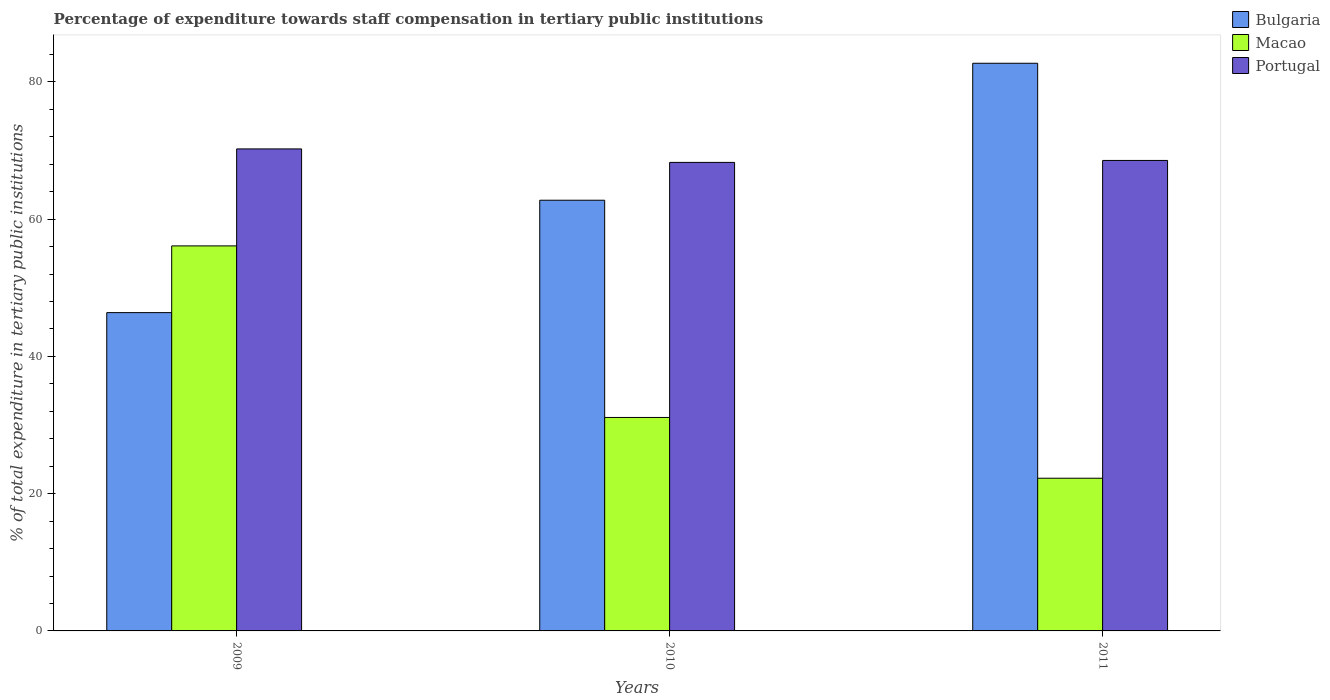Are the number of bars on each tick of the X-axis equal?
Keep it short and to the point. Yes. What is the label of the 2nd group of bars from the left?
Your answer should be compact. 2010. In how many cases, is the number of bars for a given year not equal to the number of legend labels?
Ensure brevity in your answer.  0. What is the percentage of expenditure towards staff compensation in Portugal in 2010?
Your answer should be very brief. 68.27. Across all years, what is the maximum percentage of expenditure towards staff compensation in Bulgaria?
Give a very brief answer. 82.72. Across all years, what is the minimum percentage of expenditure towards staff compensation in Portugal?
Give a very brief answer. 68.27. In which year was the percentage of expenditure towards staff compensation in Macao maximum?
Ensure brevity in your answer.  2009. What is the total percentage of expenditure towards staff compensation in Portugal in the graph?
Offer a terse response. 207.06. What is the difference between the percentage of expenditure towards staff compensation in Macao in 2009 and that in 2010?
Make the answer very short. 25. What is the difference between the percentage of expenditure towards staff compensation in Bulgaria in 2011 and the percentage of expenditure towards staff compensation in Macao in 2010?
Keep it short and to the point. 51.61. What is the average percentage of expenditure towards staff compensation in Portugal per year?
Provide a short and direct response. 69.02. In the year 2009, what is the difference between the percentage of expenditure towards staff compensation in Portugal and percentage of expenditure towards staff compensation in Macao?
Make the answer very short. 14.13. What is the ratio of the percentage of expenditure towards staff compensation in Macao in 2009 to that in 2010?
Give a very brief answer. 1.8. What is the difference between the highest and the second highest percentage of expenditure towards staff compensation in Macao?
Make the answer very short. 25. What is the difference between the highest and the lowest percentage of expenditure towards staff compensation in Portugal?
Give a very brief answer. 1.96. Is the sum of the percentage of expenditure towards staff compensation in Portugal in 2009 and 2011 greater than the maximum percentage of expenditure towards staff compensation in Bulgaria across all years?
Your response must be concise. Yes. How many bars are there?
Give a very brief answer. 9. How many years are there in the graph?
Offer a terse response. 3. What is the difference between two consecutive major ticks on the Y-axis?
Ensure brevity in your answer.  20. Does the graph contain any zero values?
Give a very brief answer. No. Does the graph contain grids?
Provide a succinct answer. No. Where does the legend appear in the graph?
Keep it short and to the point. Top right. How many legend labels are there?
Your response must be concise. 3. What is the title of the graph?
Offer a terse response. Percentage of expenditure towards staff compensation in tertiary public institutions. Does "Norway" appear as one of the legend labels in the graph?
Offer a terse response. No. What is the label or title of the X-axis?
Your answer should be very brief. Years. What is the label or title of the Y-axis?
Give a very brief answer. % of total expenditure in tertiary public institutions. What is the % of total expenditure in tertiary public institutions in Bulgaria in 2009?
Make the answer very short. 46.38. What is the % of total expenditure in tertiary public institutions in Macao in 2009?
Keep it short and to the point. 56.1. What is the % of total expenditure in tertiary public institutions of Portugal in 2009?
Give a very brief answer. 70.24. What is the % of total expenditure in tertiary public institutions in Bulgaria in 2010?
Your answer should be compact. 62.76. What is the % of total expenditure in tertiary public institutions in Macao in 2010?
Provide a succinct answer. 31.1. What is the % of total expenditure in tertiary public institutions in Portugal in 2010?
Keep it short and to the point. 68.27. What is the % of total expenditure in tertiary public institutions in Bulgaria in 2011?
Provide a succinct answer. 82.72. What is the % of total expenditure in tertiary public institutions of Macao in 2011?
Provide a succinct answer. 22.25. What is the % of total expenditure in tertiary public institutions of Portugal in 2011?
Keep it short and to the point. 68.56. Across all years, what is the maximum % of total expenditure in tertiary public institutions of Bulgaria?
Ensure brevity in your answer.  82.72. Across all years, what is the maximum % of total expenditure in tertiary public institutions of Macao?
Keep it short and to the point. 56.1. Across all years, what is the maximum % of total expenditure in tertiary public institutions in Portugal?
Ensure brevity in your answer.  70.24. Across all years, what is the minimum % of total expenditure in tertiary public institutions in Bulgaria?
Provide a succinct answer. 46.38. Across all years, what is the minimum % of total expenditure in tertiary public institutions in Macao?
Ensure brevity in your answer.  22.25. Across all years, what is the minimum % of total expenditure in tertiary public institutions in Portugal?
Your answer should be very brief. 68.27. What is the total % of total expenditure in tertiary public institutions of Bulgaria in the graph?
Provide a short and direct response. 191.86. What is the total % of total expenditure in tertiary public institutions of Macao in the graph?
Make the answer very short. 109.46. What is the total % of total expenditure in tertiary public institutions of Portugal in the graph?
Keep it short and to the point. 207.06. What is the difference between the % of total expenditure in tertiary public institutions in Bulgaria in 2009 and that in 2010?
Ensure brevity in your answer.  -16.38. What is the difference between the % of total expenditure in tertiary public institutions of Macao in 2009 and that in 2010?
Provide a succinct answer. 25. What is the difference between the % of total expenditure in tertiary public institutions of Portugal in 2009 and that in 2010?
Keep it short and to the point. 1.96. What is the difference between the % of total expenditure in tertiary public institutions in Bulgaria in 2009 and that in 2011?
Provide a succinct answer. -36.34. What is the difference between the % of total expenditure in tertiary public institutions in Macao in 2009 and that in 2011?
Make the answer very short. 33.85. What is the difference between the % of total expenditure in tertiary public institutions of Portugal in 2009 and that in 2011?
Make the answer very short. 1.68. What is the difference between the % of total expenditure in tertiary public institutions in Bulgaria in 2010 and that in 2011?
Provide a succinct answer. -19.96. What is the difference between the % of total expenditure in tertiary public institutions in Macao in 2010 and that in 2011?
Offer a terse response. 8.85. What is the difference between the % of total expenditure in tertiary public institutions in Portugal in 2010 and that in 2011?
Offer a terse response. -0.28. What is the difference between the % of total expenditure in tertiary public institutions of Bulgaria in 2009 and the % of total expenditure in tertiary public institutions of Macao in 2010?
Give a very brief answer. 15.28. What is the difference between the % of total expenditure in tertiary public institutions in Bulgaria in 2009 and the % of total expenditure in tertiary public institutions in Portugal in 2010?
Your answer should be compact. -21.89. What is the difference between the % of total expenditure in tertiary public institutions of Macao in 2009 and the % of total expenditure in tertiary public institutions of Portugal in 2010?
Give a very brief answer. -12.17. What is the difference between the % of total expenditure in tertiary public institutions in Bulgaria in 2009 and the % of total expenditure in tertiary public institutions in Macao in 2011?
Your answer should be compact. 24.13. What is the difference between the % of total expenditure in tertiary public institutions of Bulgaria in 2009 and the % of total expenditure in tertiary public institutions of Portugal in 2011?
Your response must be concise. -22.17. What is the difference between the % of total expenditure in tertiary public institutions in Macao in 2009 and the % of total expenditure in tertiary public institutions in Portugal in 2011?
Your answer should be very brief. -12.45. What is the difference between the % of total expenditure in tertiary public institutions of Bulgaria in 2010 and the % of total expenditure in tertiary public institutions of Macao in 2011?
Offer a very short reply. 40.51. What is the difference between the % of total expenditure in tertiary public institutions of Bulgaria in 2010 and the % of total expenditure in tertiary public institutions of Portugal in 2011?
Your answer should be compact. -5.8. What is the difference between the % of total expenditure in tertiary public institutions of Macao in 2010 and the % of total expenditure in tertiary public institutions of Portugal in 2011?
Provide a short and direct response. -37.45. What is the average % of total expenditure in tertiary public institutions of Bulgaria per year?
Your answer should be very brief. 63.95. What is the average % of total expenditure in tertiary public institutions in Macao per year?
Offer a very short reply. 36.49. What is the average % of total expenditure in tertiary public institutions in Portugal per year?
Provide a short and direct response. 69.02. In the year 2009, what is the difference between the % of total expenditure in tertiary public institutions in Bulgaria and % of total expenditure in tertiary public institutions in Macao?
Provide a short and direct response. -9.72. In the year 2009, what is the difference between the % of total expenditure in tertiary public institutions of Bulgaria and % of total expenditure in tertiary public institutions of Portugal?
Provide a succinct answer. -23.85. In the year 2009, what is the difference between the % of total expenditure in tertiary public institutions of Macao and % of total expenditure in tertiary public institutions of Portugal?
Offer a very short reply. -14.13. In the year 2010, what is the difference between the % of total expenditure in tertiary public institutions in Bulgaria and % of total expenditure in tertiary public institutions in Macao?
Offer a very short reply. 31.65. In the year 2010, what is the difference between the % of total expenditure in tertiary public institutions of Bulgaria and % of total expenditure in tertiary public institutions of Portugal?
Offer a terse response. -5.51. In the year 2010, what is the difference between the % of total expenditure in tertiary public institutions in Macao and % of total expenditure in tertiary public institutions in Portugal?
Your answer should be compact. -37.17. In the year 2011, what is the difference between the % of total expenditure in tertiary public institutions of Bulgaria and % of total expenditure in tertiary public institutions of Macao?
Ensure brevity in your answer.  60.47. In the year 2011, what is the difference between the % of total expenditure in tertiary public institutions in Bulgaria and % of total expenditure in tertiary public institutions in Portugal?
Offer a very short reply. 14.16. In the year 2011, what is the difference between the % of total expenditure in tertiary public institutions of Macao and % of total expenditure in tertiary public institutions of Portugal?
Provide a succinct answer. -46.3. What is the ratio of the % of total expenditure in tertiary public institutions of Bulgaria in 2009 to that in 2010?
Your response must be concise. 0.74. What is the ratio of the % of total expenditure in tertiary public institutions in Macao in 2009 to that in 2010?
Offer a very short reply. 1.8. What is the ratio of the % of total expenditure in tertiary public institutions of Portugal in 2009 to that in 2010?
Keep it short and to the point. 1.03. What is the ratio of the % of total expenditure in tertiary public institutions in Bulgaria in 2009 to that in 2011?
Your answer should be very brief. 0.56. What is the ratio of the % of total expenditure in tertiary public institutions of Macao in 2009 to that in 2011?
Make the answer very short. 2.52. What is the ratio of the % of total expenditure in tertiary public institutions of Portugal in 2009 to that in 2011?
Your answer should be compact. 1.02. What is the ratio of the % of total expenditure in tertiary public institutions in Bulgaria in 2010 to that in 2011?
Your response must be concise. 0.76. What is the ratio of the % of total expenditure in tertiary public institutions in Macao in 2010 to that in 2011?
Make the answer very short. 1.4. What is the difference between the highest and the second highest % of total expenditure in tertiary public institutions in Bulgaria?
Give a very brief answer. 19.96. What is the difference between the highest and the second highest % of total expenditure in tertiary public institutions of Macao?
Keep it short and to the point. 25. What is the difference between the highest and the second highest % of total expenditure in tertiary public institutions of Portugal?
Give a very brief answer. 1.68. What is the difference between the highest and the lowest % of total expenditure in tertiary public institutions of Bulgaria?
Give a very brief answer. 36.34. What is the difference between the highest and the lowest % of total expenditure in tertiary public institutions in Macao?
Your response must be concise. 33.85. What is the difference between the highest and the lowest % of total expenditure in tertiary public institutions in Portugal?
Offer a terse response. 1.96. 